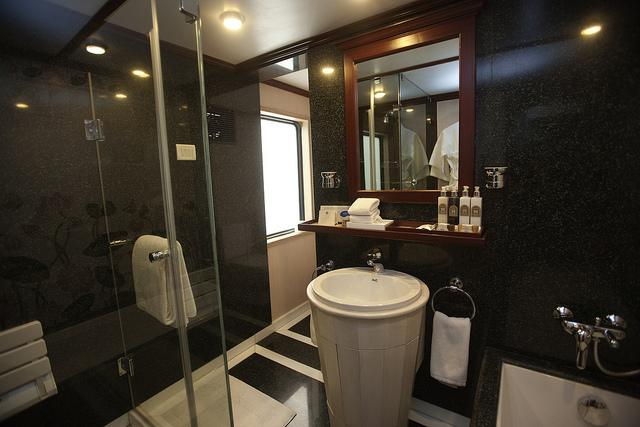What shape is the mirror hanging on the wall with some wooden planks? rectangle 